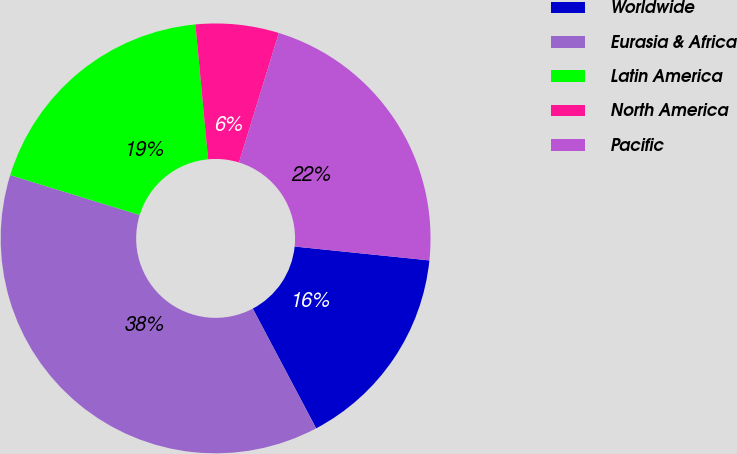Convert chart. <chart><loc_0><loc_0><loc_500><loc_500><pie_chart><fcel>Worldwide<fcel>Eurasia & Africa<fcel>Latin America<fcel>North America<fcel>Pacific<nl><fcel>15.62%<fcel>37.5%<fcel>18.75%<fcel>6.25%<fcel>21.88%<nl></chart> 